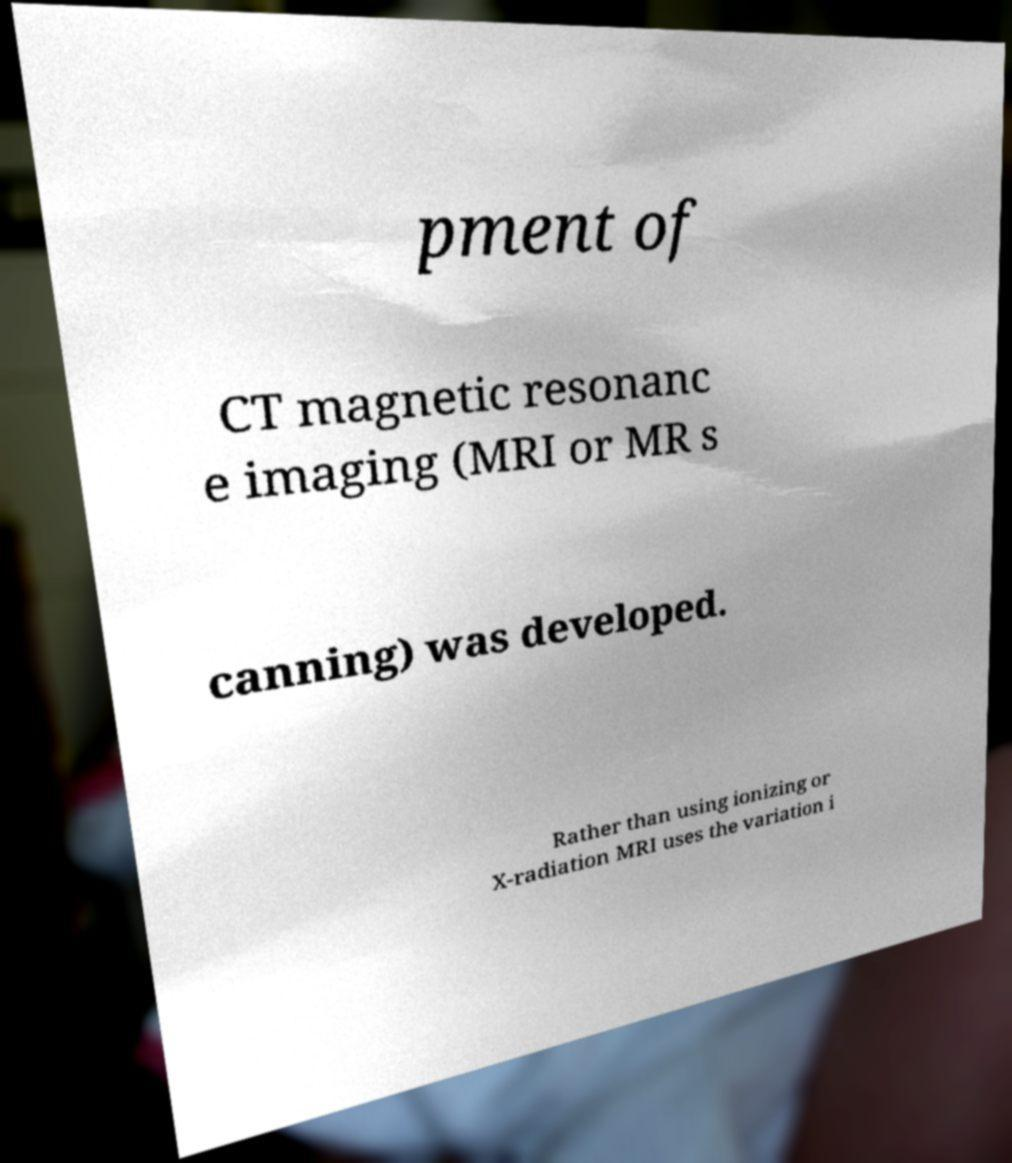There's text embedded in this image that I need extracted. Can you transcribe it verbatim? pment of CT magnetic resonanc e imaging (MRI or MR s canning) was developed. Rather than using ionizing or X-radiation MRI uses the variation i 